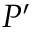<formula> <loc_0><loc_0><loc_500><loc_500>P ^ { \prime }</formula> 